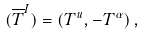<formula> <loc_0><loc_0><loc_500><loc_500>( \overline { T } ^ { I } ) = ( T ^ { u } , - T ^ { \alpha } ) \, ,</formula> 